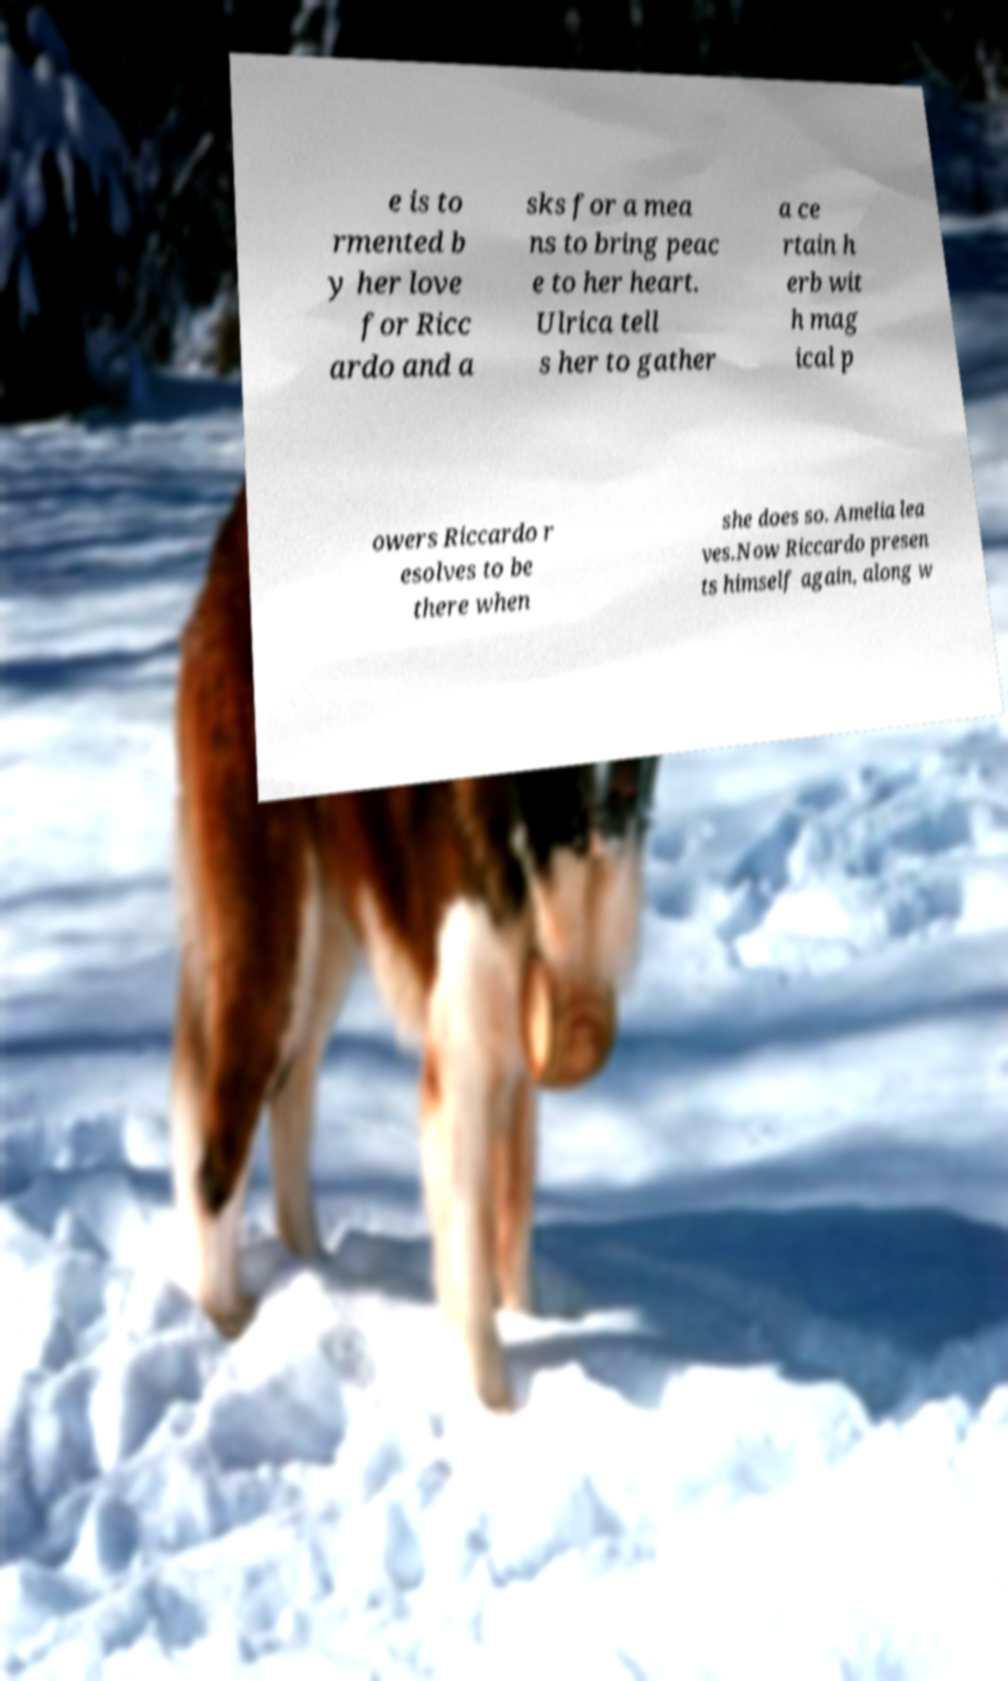What messages or text are displayed in this image? I need them in a readable, typed format. e is to rmented b y her love for Ricc ardo and a sks for a mea ns to bring peac e to her heart. Ulrica tell s her to gather a ce rtain h erb wit h mag ical p owers Riccardo r esolves to be there when she does so. Amelia lea ves.Now Riccardo presen ts himself again, along w 